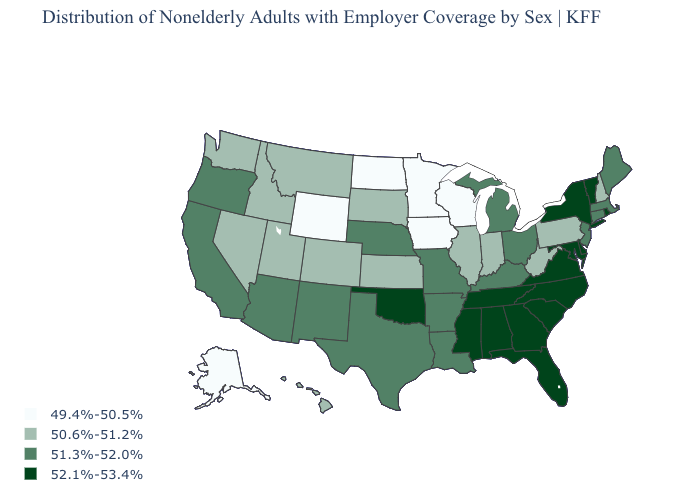Is the legend a continuous bar?
Give a very brief answer. No. Which states hav the highest value in the West?
Short answer required. Arizona, California, New Mexico, Oregon. Does North Dakota have the lowest value in the USA?
Be succinct. Yes. What is the value of Minnesota?
Short answer required. 49.4%-50.5%. Does Missouri have a higher value than Florida?
Short answer required. No. What is the value of Virginia?
Give a very brief answer. 52.1%-53.4%. What is the value of Illinois?
Give a very brief answer. 50.6%-51.2%. What is the lowest value in states that border Connecticut?
Keep it brief. 51.3%-52.0%. What is the value of Iowa?
Answer briefly. 49.4%-50.5%. What is the highest value in the South ?
Keep it brief. 52.1%-53.4%. What is the highest value in states that border Colorado?
Write a very short answer. 52.1%-53.4%. What is the value of Missouri?
Short answer required. 51.3%-52.0%. What is the value of Idaho?
Concise answer only. 50.6%-51.2%. Name the states that have a value in the range 52.1%-53.4%?
Quick response, please. Alabama, Delaware, Florida, Georgia, Maryland, Mississippi, New York, North Carolina, Oklahoma, Rhode Island, South Carolina, Tennessee, Vermont, Virginia. What is the value of Kentucky?
Short answer required. 51.3%-52.0%. 